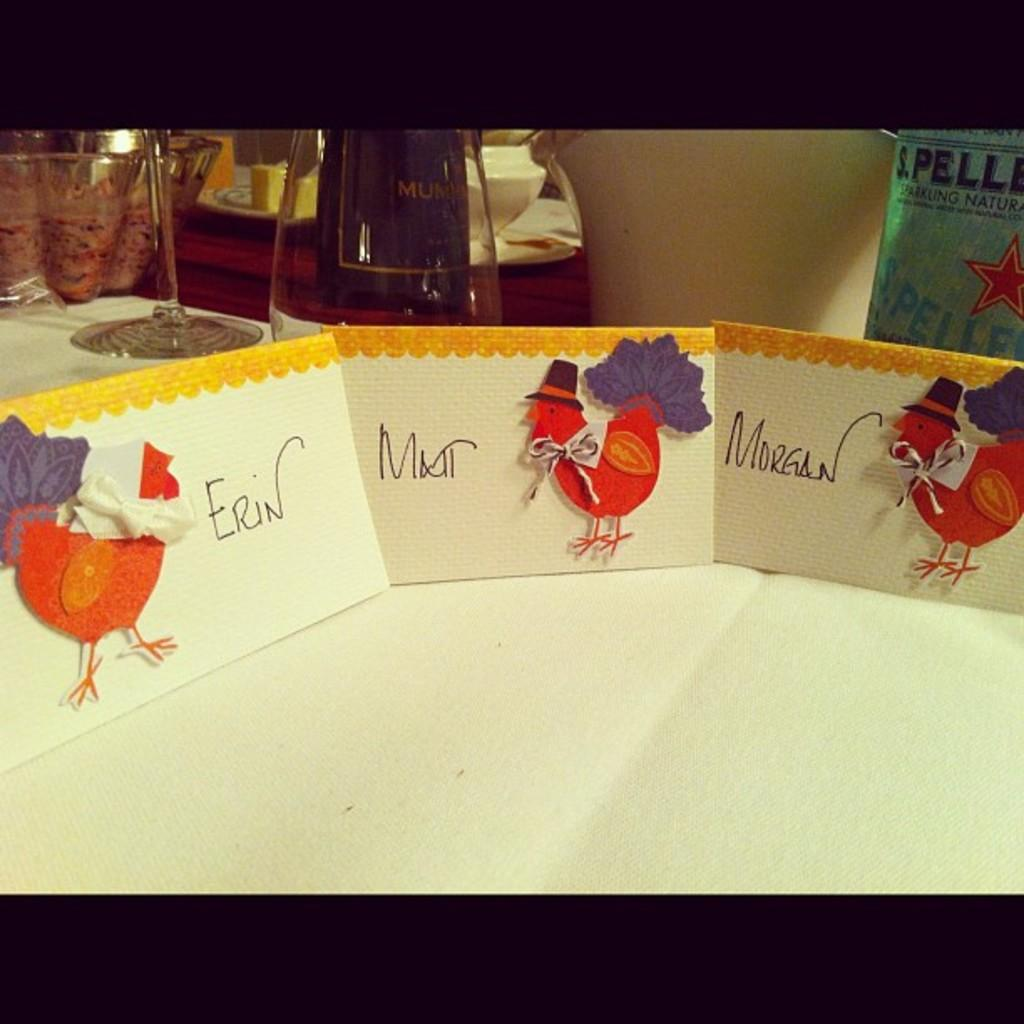<image>
Share a concise interpretation of the image provided. A group of three Thanksgiving cards for Erin, Matt and Morgan lined up on a table. 